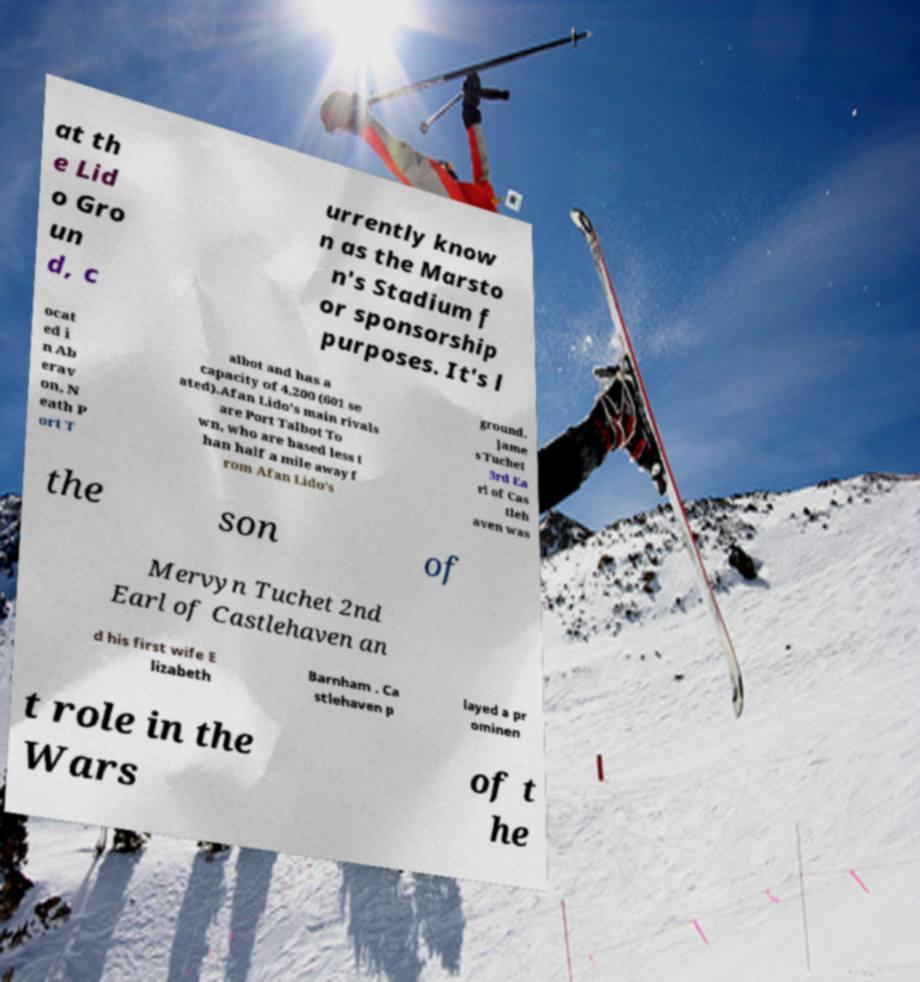I need the written content from this picture converted into text. Can you do that? at th e Lid o Gro un d, c urrently know n as the Marsto n's Stadium f or sponsorship purposes. It's l ocat ed i n Ab erav on, N eath P ort T albot and has a capacity of 4,200 (601 se ated).Afan Lido's main rivals are Port Talbot To wn, who are based less t han half a mile away f rom Afan Lido's ground. Jame s Tuchet 3rd Ea rl of Cas tleh aven was the son of Mervyn Tuchet 2nd Earl of Castlehaven an d his first wife E lizabeth Barnham . Ca stlehaven p layed a pr ominen t role in the Wars of t he 